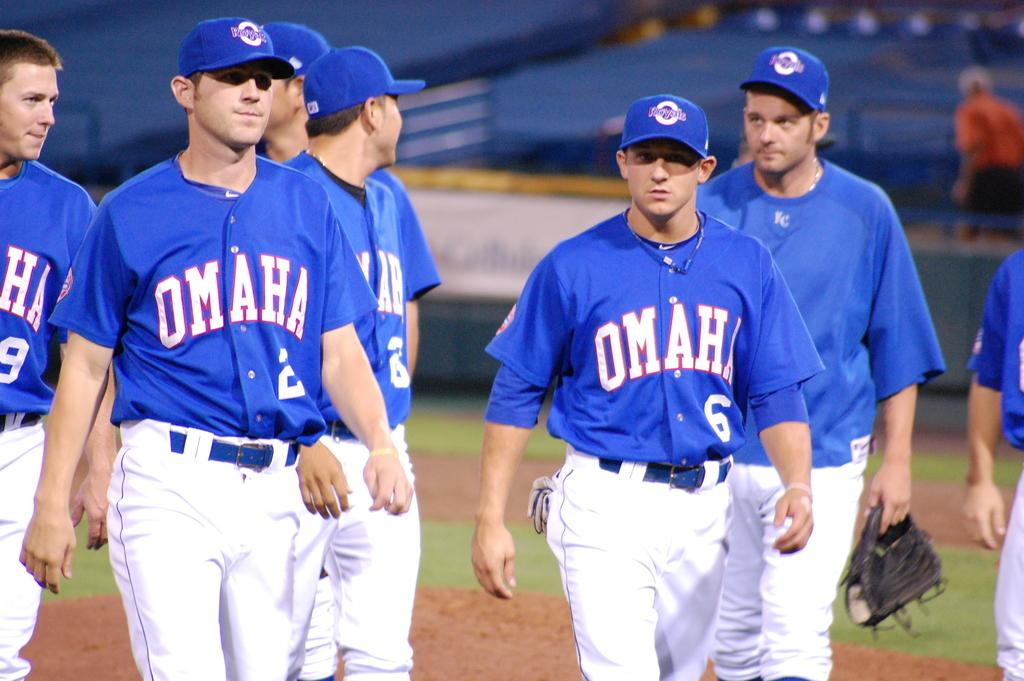<image>
Provide a brief description of the given image. A group of baseball players from the Omaha team. 